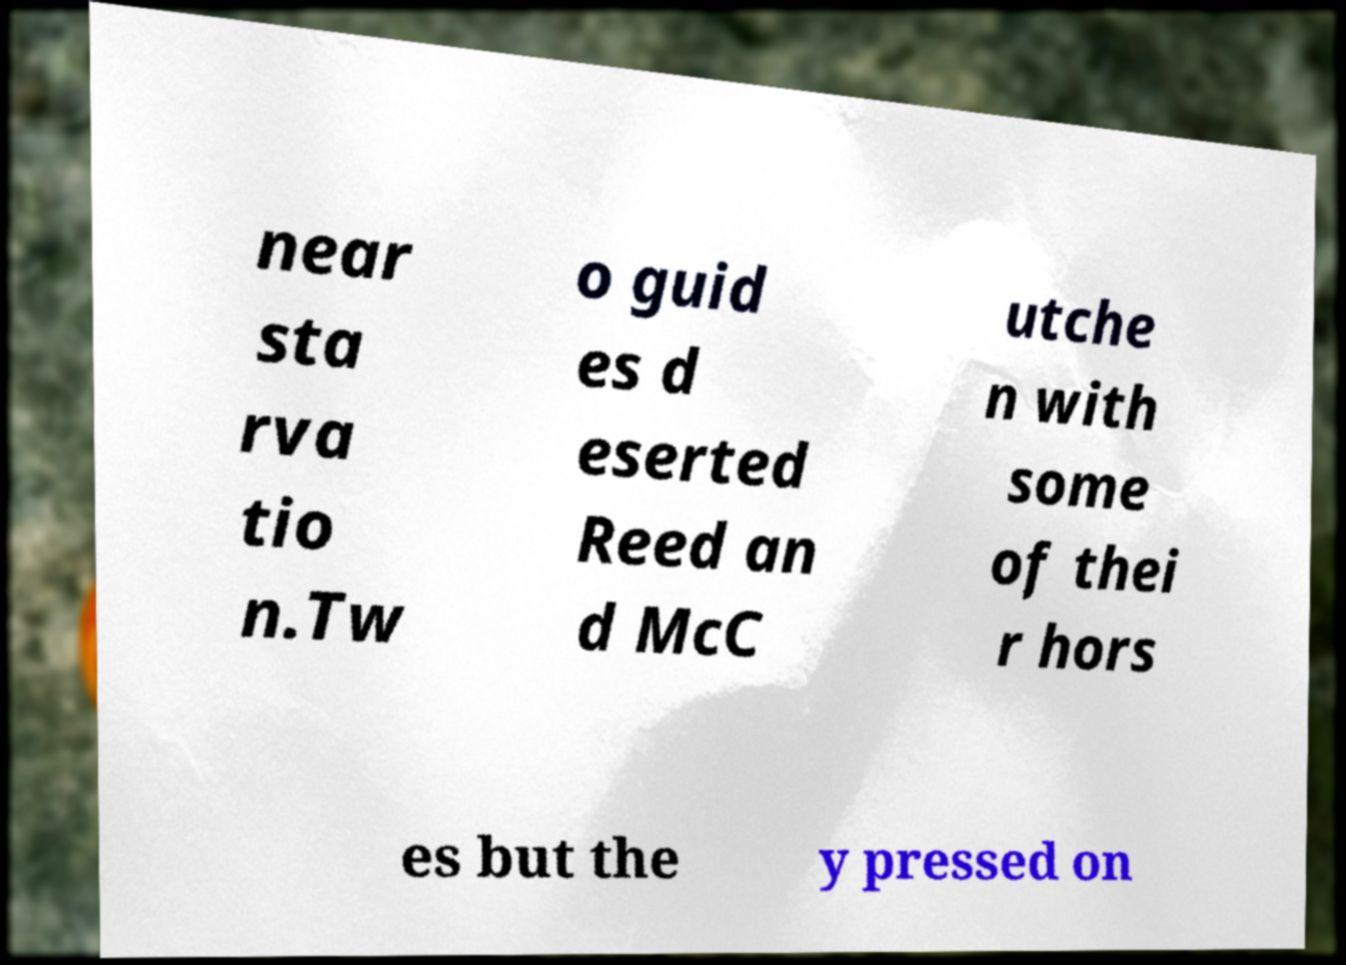Please read and relay the text visible in this image. What does it say? near sta rva tio n.Tw o guid es d eserted Reed an d McC utche n with some of thei r hors es but the y pressed on 